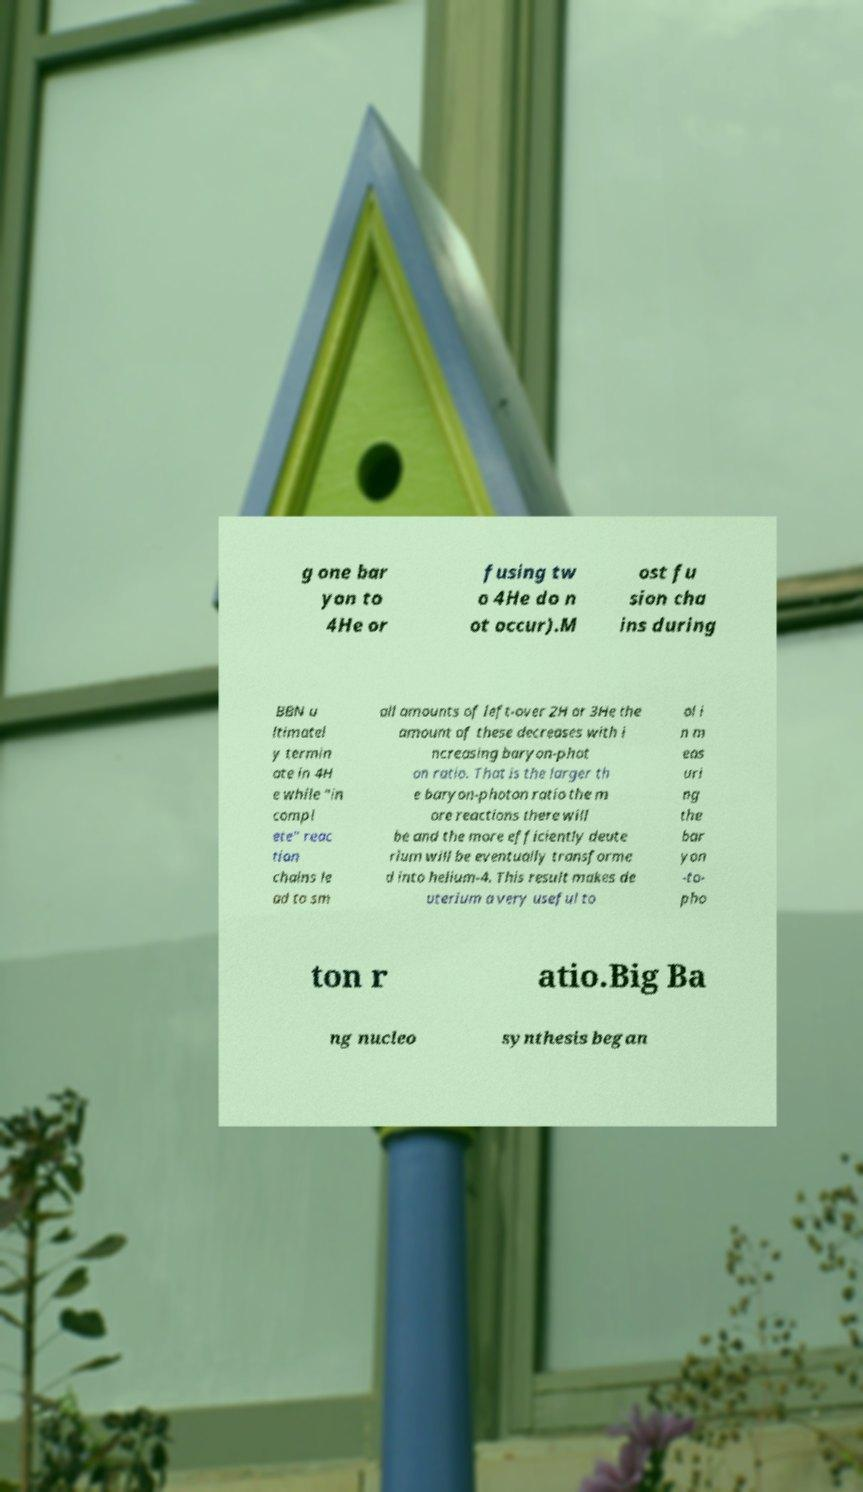What messages or text are displayed in this image? I need them in a readable, typed format. g one bar yon to 4He or fusing tw o 4He do n ot occur).M ost fu sion cha ins during BBN u ltimatel y termin ate in 4H e while "in compl ete" reac tion chains le ad to sm all amounts of left-over 2H or 3He the amount of these decreases with i ncreasing baryon-phot on ratio. That is the larger th e baryon-photon ratio the m ore reactions there will be and the more efficiently deute rium will be eventually transforme d into helium-4. This result makes de uterium a very useful to ol i n m eas uri ng the bar yon -to- pho ton r atio.Big Ba ng nucleo synthesis began 